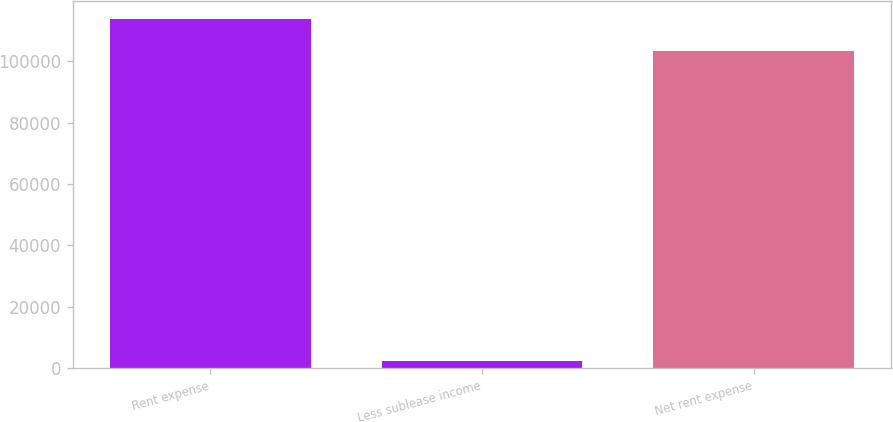Convert chart. <chart><loc_0><loc_0><loc_500><loc_500><bar_chart><fcel>Rent expense<fcel>Less sublease income<fcel>Net rent expense<nl><fcel>113827<fcel>2330<fcel>103479<nl></chart> 